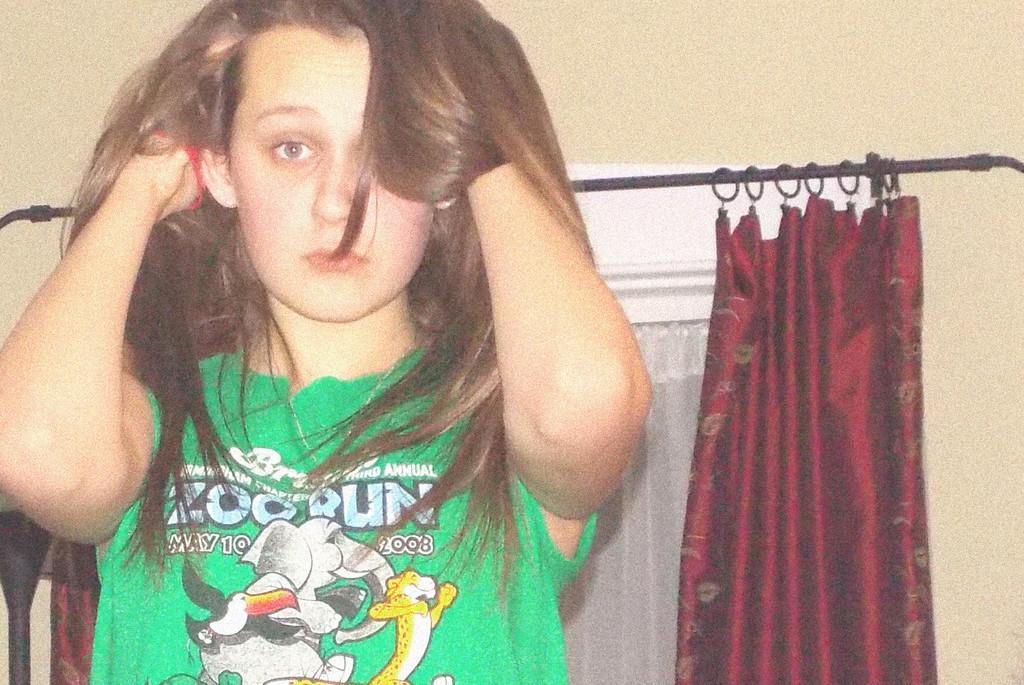In one or two sentences, can you explain what this image depicts? On the left side, there is a woman in green color T-shirt, keeping both hands in her hair. In the background, there are red color curtains and there is a wall. 